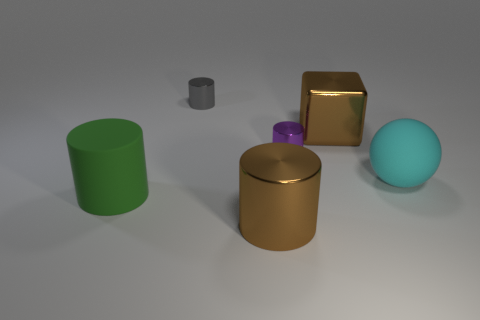There is a large rubber object that is behind the big matte object left of the big sphere; what color is it?
Provide a short and direct response. Cyan. Is the material of the small purple cylinder the same as the large green object?
Your answer should be very brief. No. Is there a large metal thing that has the same shape as the big green rubber object?
Your answer should be very brief. Yes. There is a large metallic object that is in front of the large green thing; does it have the same color as the big block?
Your answer should be very brief. Yes. Do the brown thing that is to the left of the shiny block and the brown thing that is behind the big cyan thing have the same size?
Provide a short and direct response. Yes. What size is the thing that is made of the same material as the cyan sphere?
Provide a succinct answer. Large. How many large objects are behind the big green cylinder and in front of the big brown block?
Keep it short and to the point. 1. How many objects are tiny yellow things or brown shiny objects behind the cyan rubber thing?
Provide a short and direct response. 1. What shape is the shiny thing that is the same color as the big shiny cylinder?
Provide a succinct answer. Cube. What color is the small cylinder in front of the large brown metallic block?
Keep it short and to the point. Purple. 